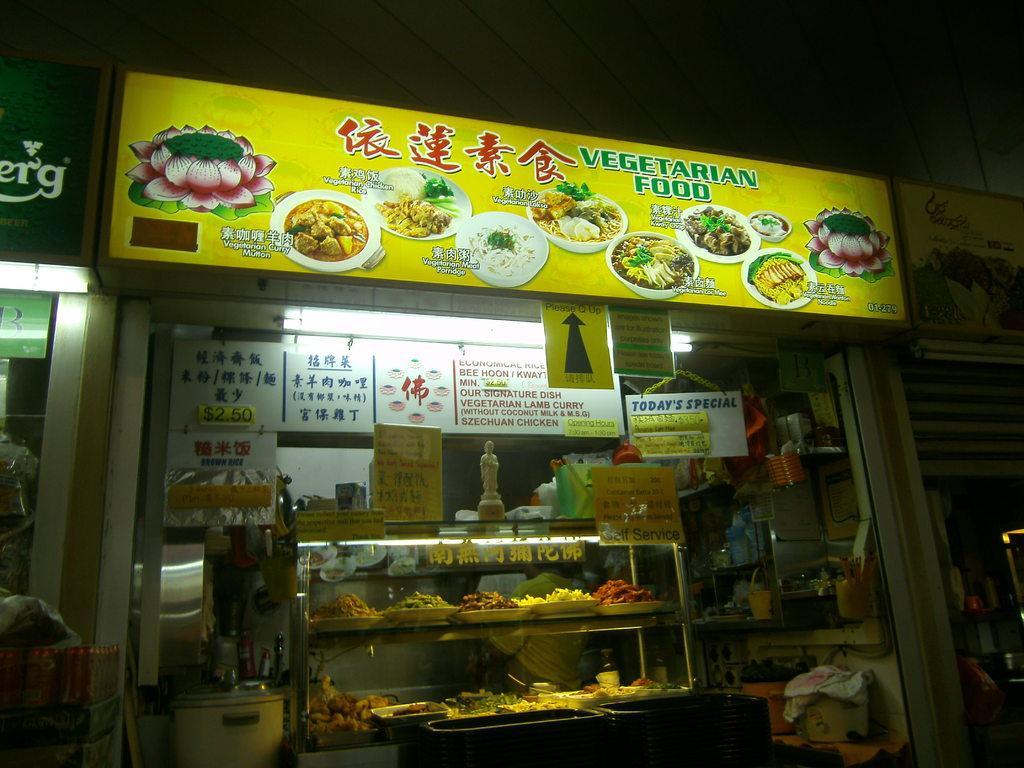Can you describe this image briefly? In this image we can see a store, on top of it there is a board with some text and images on it, inside the store there are posters, various food items in the racks and a few other objects. 